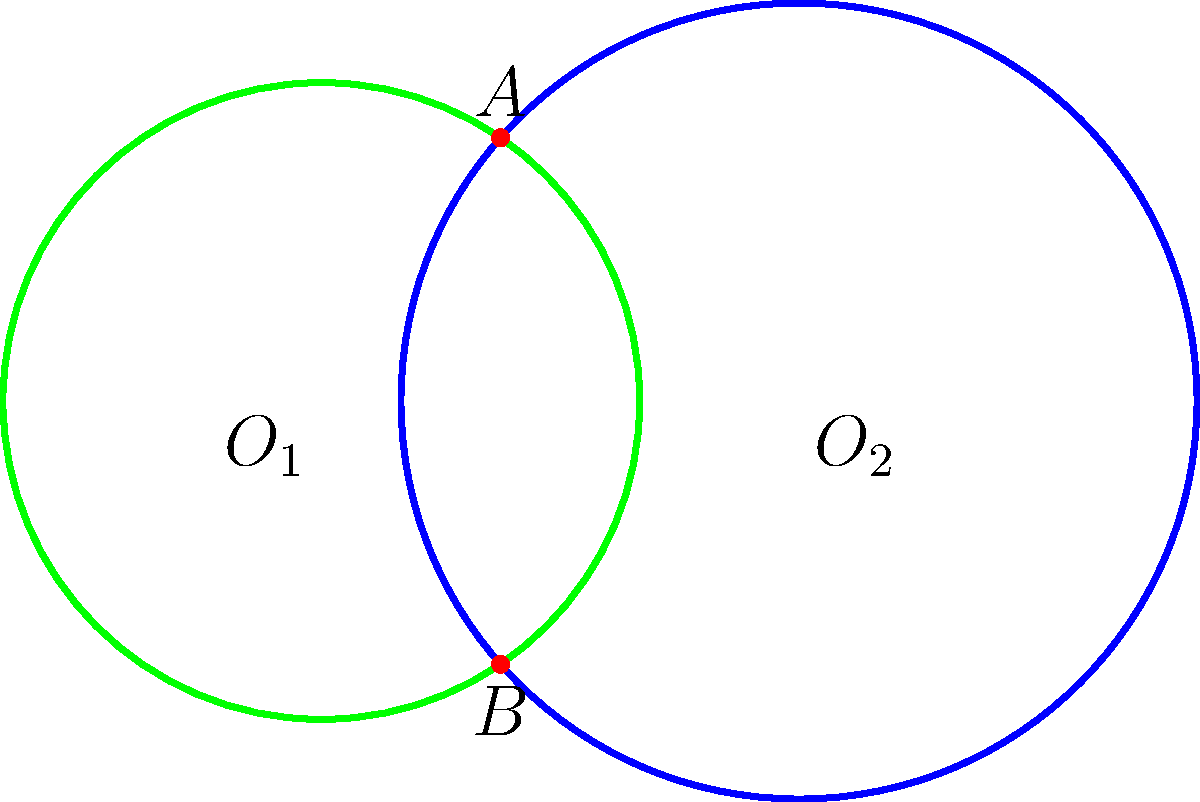As part of your eco-friendly product development, you're designing a new biodegradable packaging solution. The design involves overlapping circular patterns. Two circles with radii 2 cm and 2.5 cm have their centers 3 cm apart. Calculate the area of the overlapping region to determine the amount of material needed for the intersection pattern. Round your answer to two decimal places. Let's solve this step-by-step:

1) First, we need to find the distance between the points of intersection (chord length):
   Let's call this distance $d$.

2) We can use the formula: $d^2 = 4R^2 - a^2$
   Where $R$ is the radius of the larger circle and $a$ is the distance from the center of the larger circle to the chord.

3) To find $a$, we can use the Pythagorean theorem:
   $a^2 + (\frac{d}{2})^2 = 2.5^2$
   $(3-a)^2 + (\frac{d}{2})^2 = 2^2$

4) Subtracting these equations:
   $a^2 - (3-a)^2 = 2.5^2 - 2^2$
   $a^2 - (9-6a+a^2) = 6.25 - 4$
   $6a - 9 = 2.25$
   $6a = 11.25$
   $a = 1.875$

5) Now we can find $d$:
   $d^2 = 4(2.5^2) - 1.875^2$
   $d^2 = 25 - 3.515625 = 21.484375$
   $d = \sqrt{21.484375} \approx 4.635$ cm

6) The area of the overlapping region is the sum of two circular segments.
   For each segment, the area is: $A = R^2 \arccos(\frac{a}{R}) - a\sqrt{R^2-a^2}$

7) For the larger circle:
   $A_1 = 2.5^2 \arccos(\frac{1.875}{2.5}) - 1.875\sqrt{2.5^2-1.875^2}$

8) For the smaller circle:
   $A_2 = 2^2 \arccos(\frac{3-1.875}{2}) - (3-1.875)\sqrt{2^2-(3-1.875)^2}$

9) Total area: $A_{total} = A_1 + A_2 \approx 2.39$ cm²
Answer: 2.39 cm² 